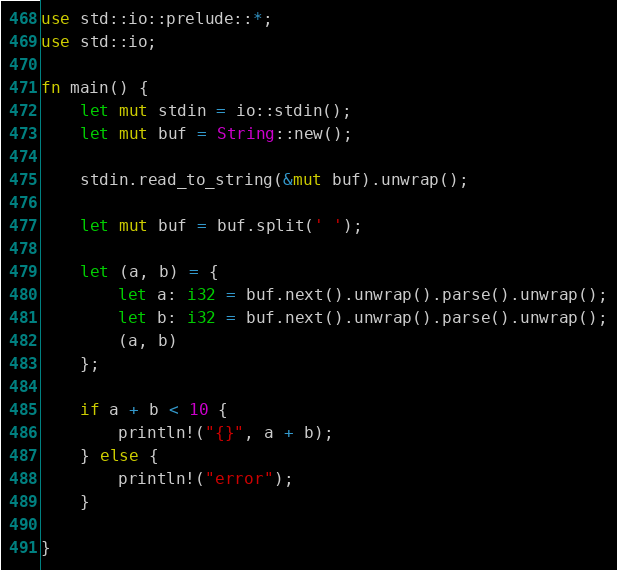<code> <loc_0><loc_0><loc_500><loc_500><_Rust_>use std::io::prelude::*;
use std::io;

fn main() {
    let mut stdin = io::stdin();
    let mut buf = String::new();

    stdin.read_to_string(&mut buf).unwrap();
    
    let mut buf = buf.split(' ');

    let (a, b) = {
        let a: i32 = buf.next().unwrap().parse().unwrap();
        let b: i32 = buf.next().unwrap().parse().unwrap();
        (a, b)
    };
    
    if a + b < 10 {
        println!("{}", a + b);
    } else {
        println!("error");
    }

}</code> 